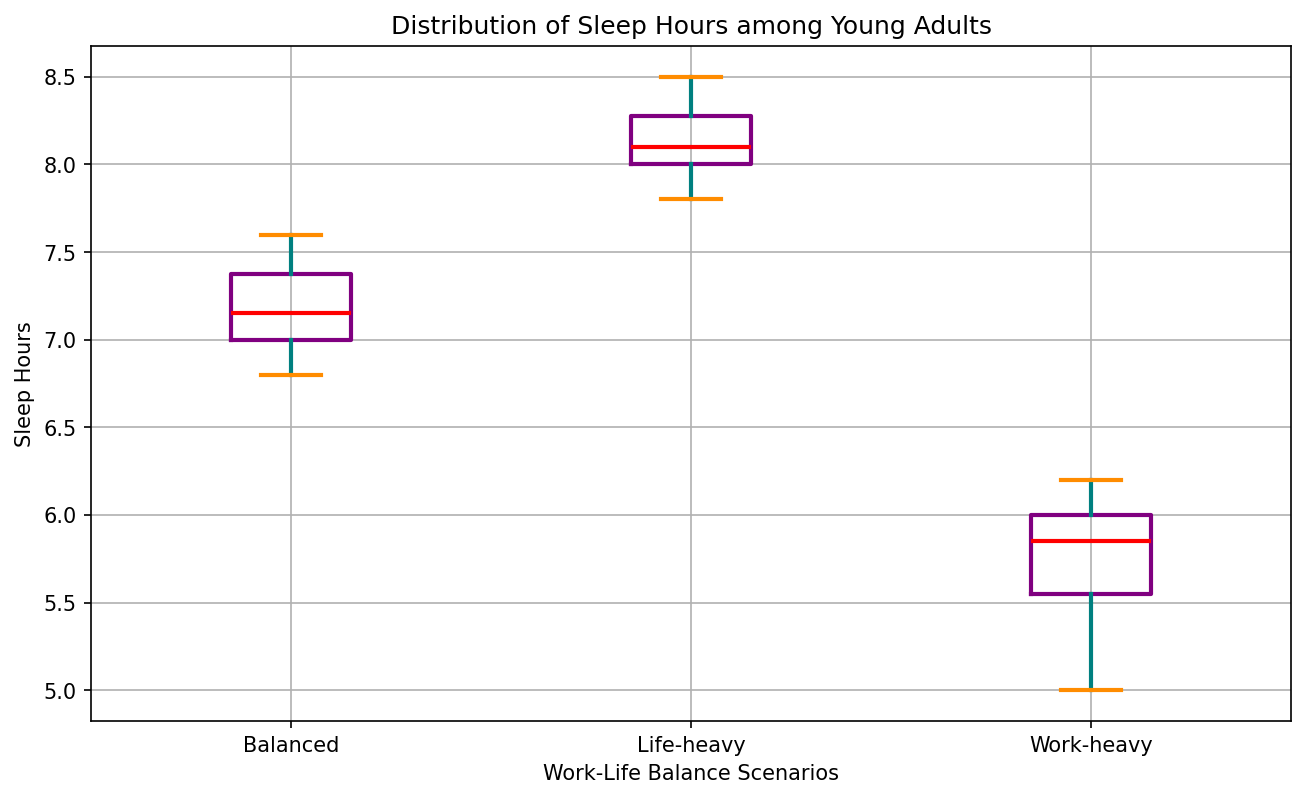What is the median sleep hours for the Work-heavy scenario? By looking at the visual representation inside the box for the Work-heavy scenario, the median is marked by a red line, which is at about 5.8 hours.
Answer: 5.8 How do the median sleep hours for the Balanced and Life-heavy scenarios compare? The red line for the Balanced scenario shows a median of around 7.2 hours, while for the Life-heavy scenario, it's around 8.1 hours. Comparing these numbers, the Life-heavy scenario has a higher median sleep hour value.
Answer: Life-heavy has more Which scenario shows the most variation in sleep hours based on the interquartile range (IQR)? The interquartile range (IQR) is visualized by the height of the box. The Work-heavy scenario has the tallest box, indicating the most variation.
Answer: Work-heavy What is the difference between the maximum sleep hours in the Balanced and Life-heavy scenarios? The top whisker of the Balanced scenario reaches approximately 7.6 hours, while the Life-heavy scenario reaches 8.5 hours. The difference is 8.5 - 7.6, which is 0.9 hours.
Answer: 0.9 hours Are there any outliers in the dataset? If yes, which scenario(s) have outliers? Outliers are represented by the green markers outside the whiskers. None of the scenarios have any green markers or circles which means there are no outliers in this dataset.
Answer: No Which scenario has the least median sleep hours and by how much is it less than the Balanced scenario? The Work-heavy scenario has the least median sleep hours at approximately 5.8 hours. The Balanced scenario's median is about 7.2 hours. The difference is 7.2 - 5.8 = 1.4 hours.
Answer: 1.4 hours What insight can be drawn about the sleep patterns of young adults with a Life-heavy work-life balance based on this plot? The Life-heavy scenario not only has the highest median sleep hours but also the highest maximum sleep hours falling around 8.5 hours. The minimum sleep hours almost correspond to what is considered a balanced sleep pattern. This suggests that young adults with a Life-heavy balance tend to sleep more on average compared to other scenarios.
Answer: Life-heavy sleep more How does the lower quartile (25th percentile) of the Work-heavy scenario compare to the lower quartile of the Balanced scenario? The bottom edge of the box represents the 25th percentile. For Work-heavy, it is around 5.5 hours, and for Balanced, it is approximately 6.8 hours. Thus, the lower quartile for Balanced is higher than that of Work-heavy.
Answer: Balanced is higher How many hours more is the 75th percentile sleep hour of the Balanced scenario compared to the median sleep hour of the Work-heavy scenario? The 75th percentile for Balanced is around 7.4 hours. The median of the Work-heavy scenario is approximately 5.8 hours. The difference is 7.4 - 5.8 = 1.6 hours.
Answer: 1.6 hours 